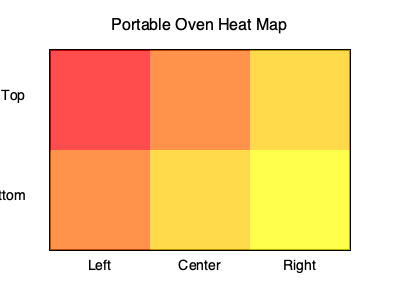Based on the heat map of a portable oven, which area has the highest temperature, and what implications does this have for food placement in food truck operations? To answer this question, we need to analyze the heat map and understand its implications for food truck operations:

1. Interpret the heat map:
   - Red indicates the highest temperature
   - Orange represents medium-high temperature
   - Yellow indicates lower temperature

2. Identify the hottest area:
   - The top-left corner of the oven is colored red, indicating the highest temperature

3. Understand temperature distribution:
   - Temperature decreases from left to right and top to bottom
   - The bottom-right corner has the lowest temperature

4. Implications for food placement:
   a) Foods requiring high heat (e.g., pizza, roasting) should be placed in the top-left area
   b) Foods needing moderate heat (e.g., baking bread) can be placed in the center or top-right
   c) Foods requiring lower heat (e.g., keeping dishes warm) should be placed in the bottom-right

5. Operational considerations:
   - Rotate foods during cooking for even heating
   - Use the temperature variation to cook multiple dishes simultaneously
   - Adjust cooking times based on food placement within the oven

6. Efficiency in food truck operations:
   - Maximize oven space by strategically placing different foods
   - Reduce energy consumption by utilizing the natural heat distribution
   - Improve cooking speed and consistency by understanding the oven's heat pattern
Answer: Top-left; optimal food placement for efficient cooking and energy use in food trucks 